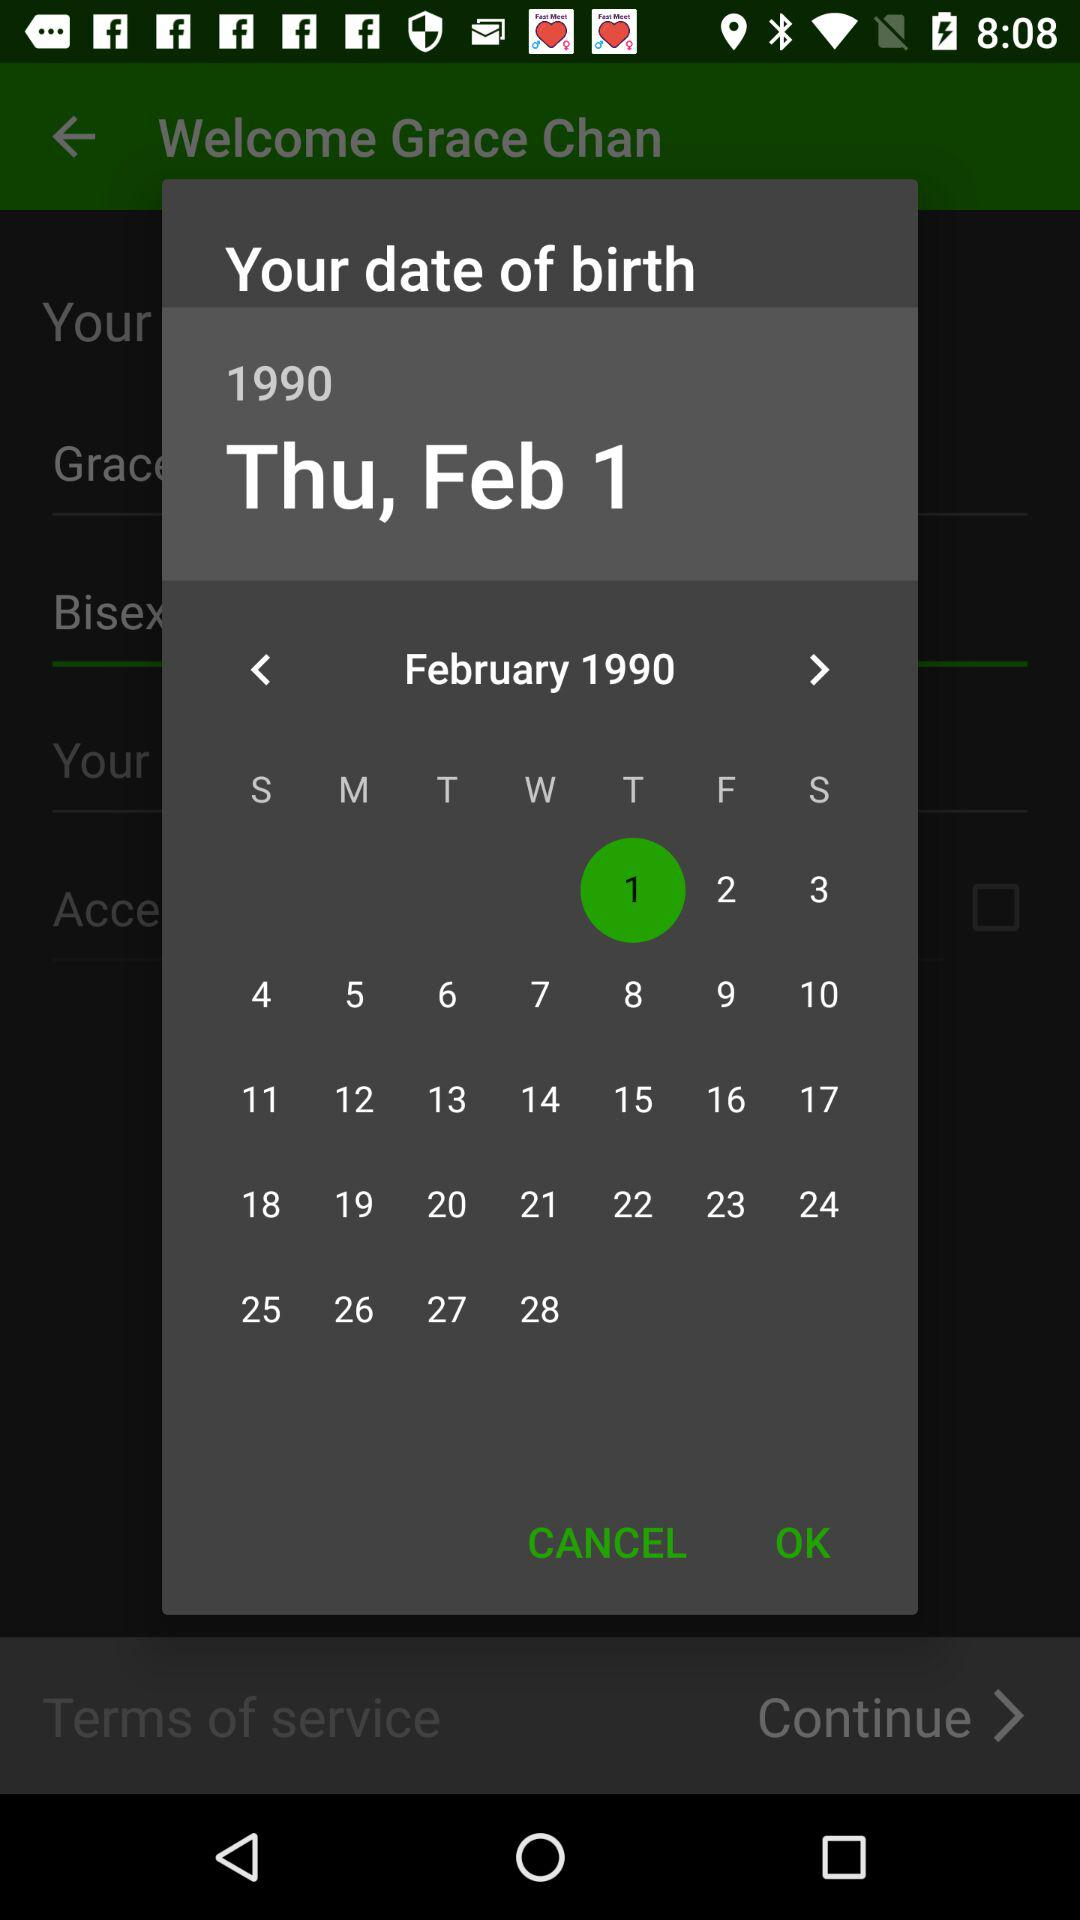What is the date of birth? The date of birth is Thursday, February 1, 1990. 